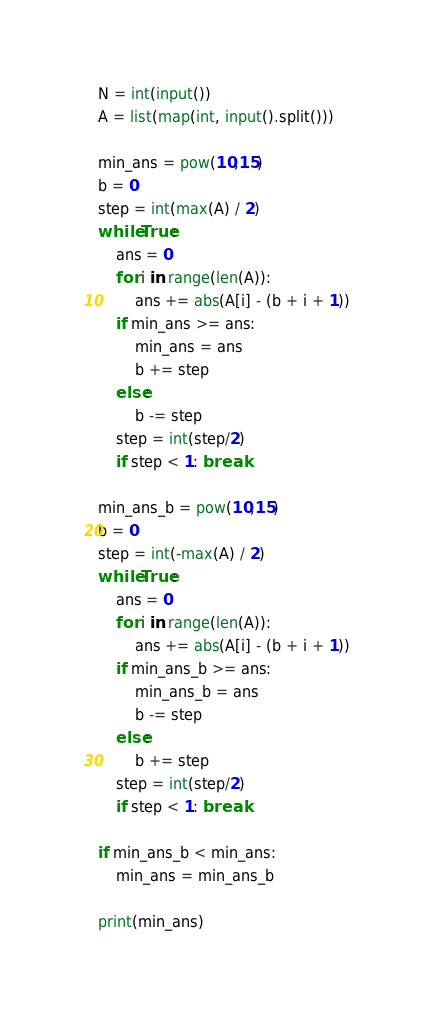<code> <loc_0><loc_0><loc_500><loc_500><_Python_>N = int(input())
A = list(map(int, input().split()))

min_ans = pow(10,15)
b = 0
step = int(max(A) / 2)
while True:
    ans = 0
    for i in range(len(A)):
        ans += abs(A[i] - (b + i + 1))
    if min_ans >= ans:
        min_ans = ans
        b += step
    else:
        b -= step
    step = int(step/2)
    if step < 1: break

min_ans_b = pow(10,15)
b = 0
step = int(-max(A) / 2)
while True:
    ans = 0
    for i in range(len(A)):
        ans += abs(A[i] - (b + i + 1))
    if min_ans_b >= ans:
        min_ans_b = ans
        b -= step
    else:
        b += step
    step = int(step/2)
    if step < 1: break

if min_ans_b < min_ans:
    min_ans = min_ans_b

print(min_ans)</code> 